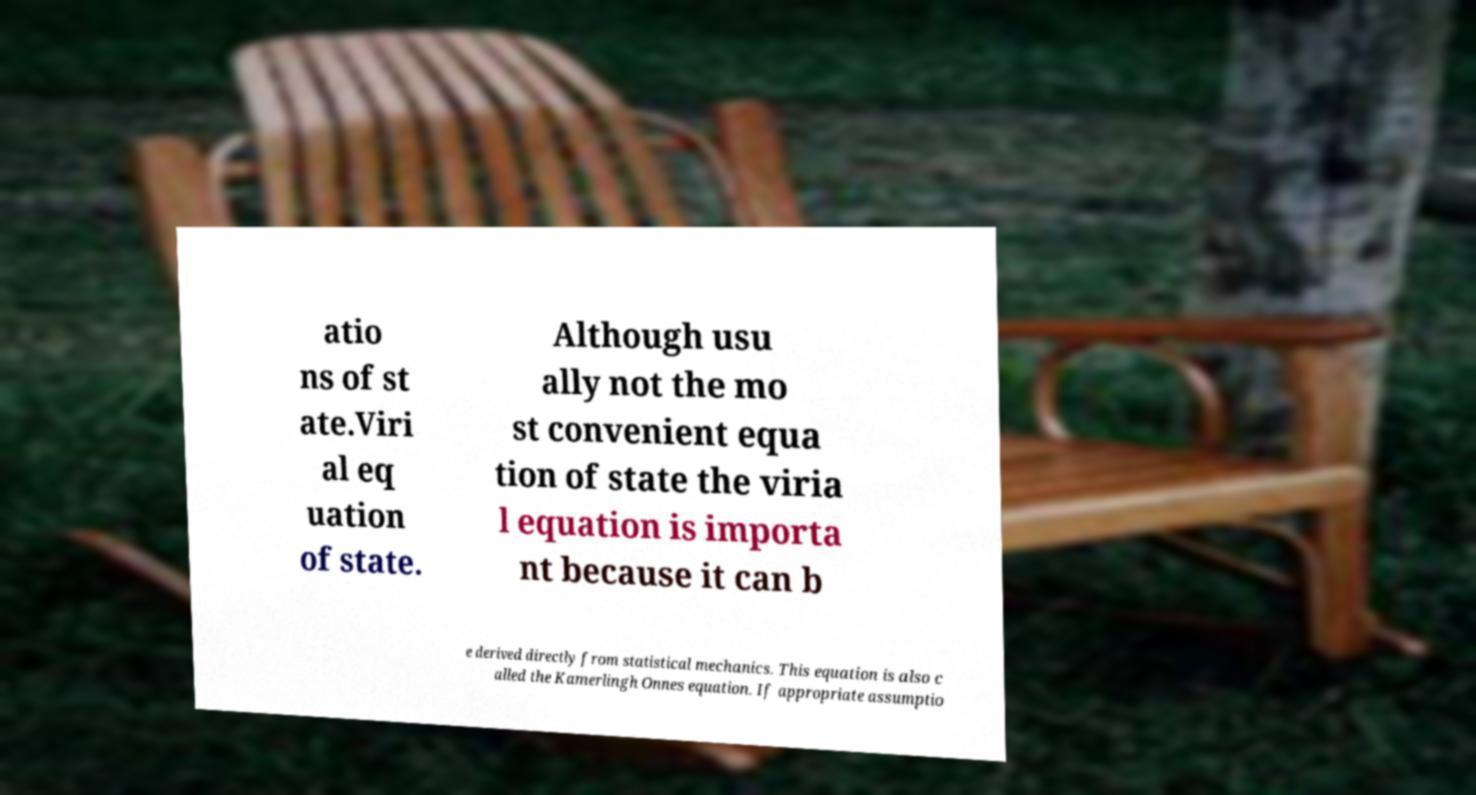Please identify and transcribe the text found in this image. atio ns of st ate.Viri al eq uation of state. Although usu ally not the mo st convenient equa tion of state the viria l equation is importa nt because it can b e derived directly from statistical mechanics. This equation is also c alled the Kamerlingh Onnes equation. If appropriate assumptio 